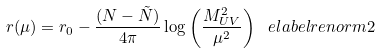<formula> <loc_0><loc_0><loc_500><loc_500>r ( \mu ) = r _ { 0 } - \frac { ( N - \tilde { N } ) } { 4 \pi } \log \left ( \frac { M _ { U V } ^ { 2 } } { \mu ^ { 2 } } \right ) \ e l a b e l { r e n o r m 2 }</formula> 